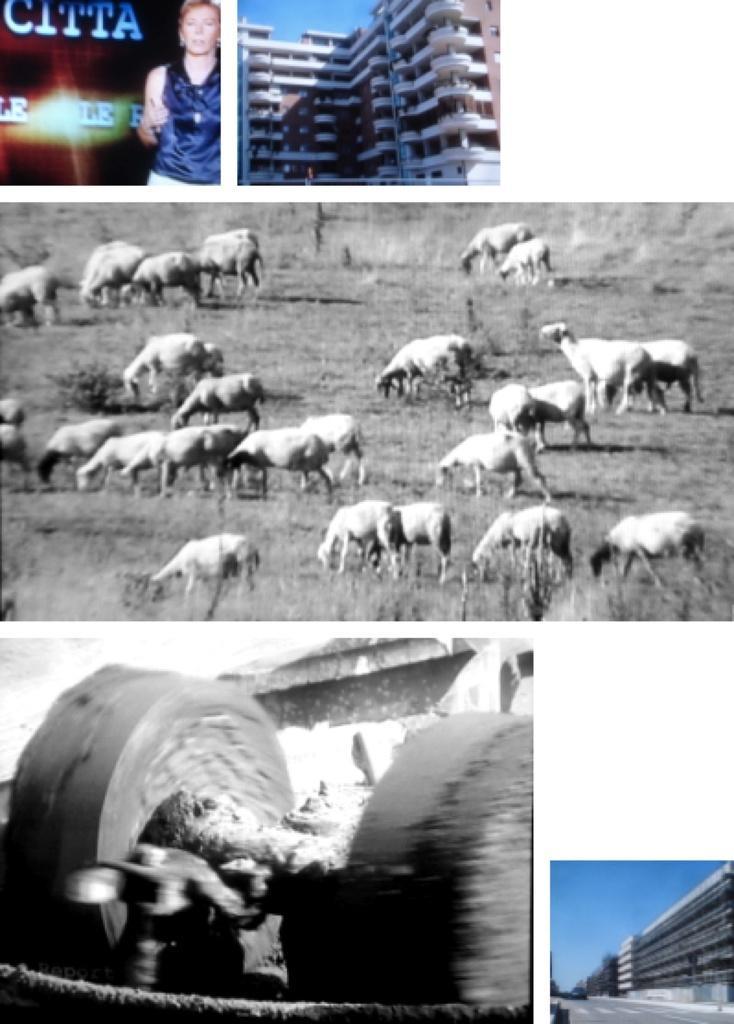Please provide a concise description of this image. In this image we can see collage of buildings, person and animals. 